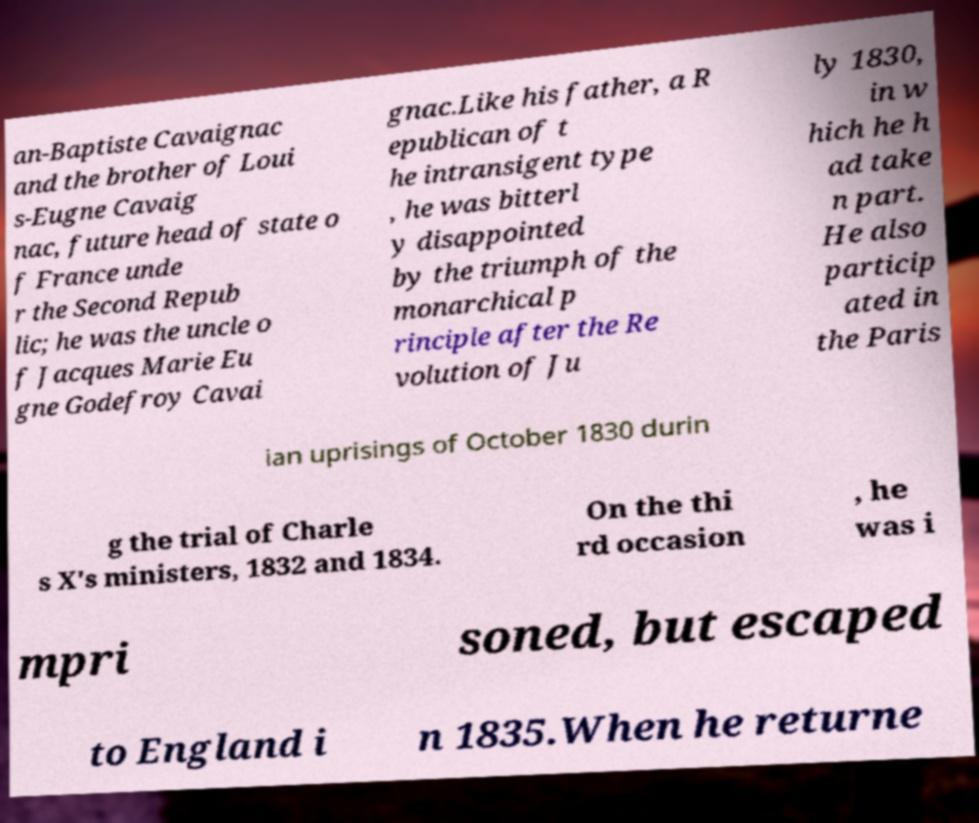For documentation purposes, I need the text within this image transcribed. Could you provide that? an-Baptiste Cavaignac and the brother of Loui s-Eugne Cavaig nac, future head of state o f France unde r the Second Repub lic; he was the uncle o f Jacques Marie Eu gne Godefroy Cavai gnac.Like his father, a R epublican of t he intransigent type , he was bitterl y disappointed by the triumph of the monarchical p rinciple after the Re volution of Ju ly 1830, in w hich he h ad take n part. He also particip ated in the Paris ian uprisings of October 1830 durin g the trial of Charle s X's ministers, 1832 and 1834. On the thi rd occasion , he was i mpri soned, but escaped to England i n 1835.When he returne 